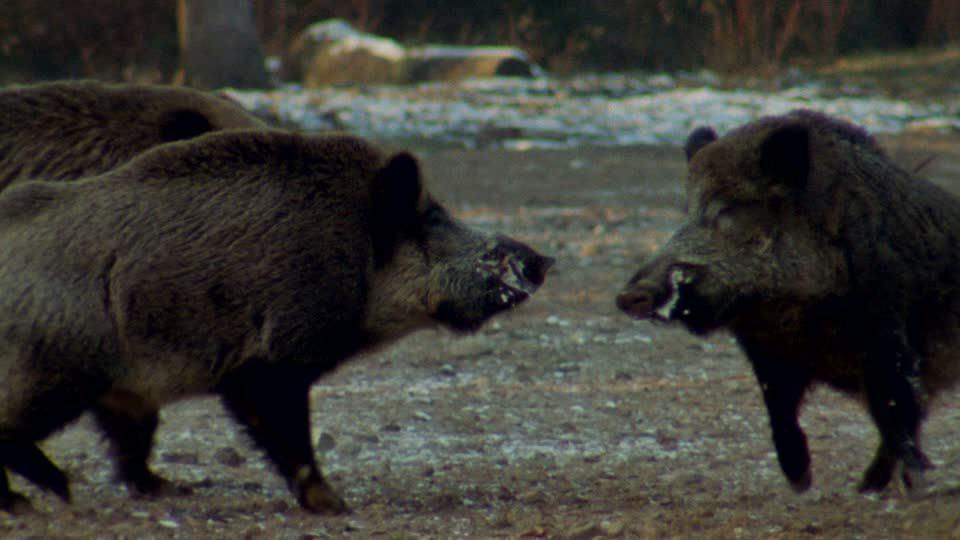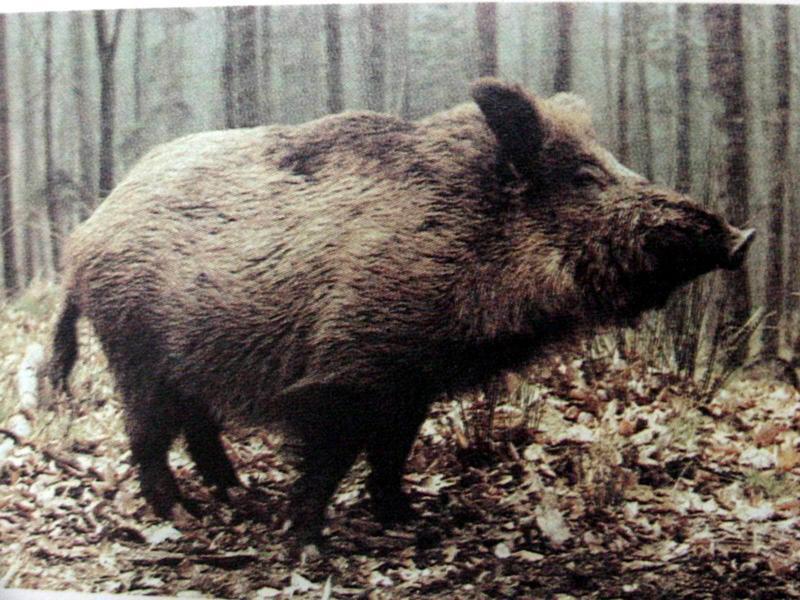The first image is the image on the left, the second image is the image on the right. For the images shown, is this caption "Each image includes a pair of animals facing-off aggressively, and the right image features a boar with its mouth open baring fangs." true? Answer yes or no. No. The first image is the image on the left, the second image is the image on the right. Considering the images on both sides, is "There is a single animal in the right image." valid? Answer yes or no. Yes. 